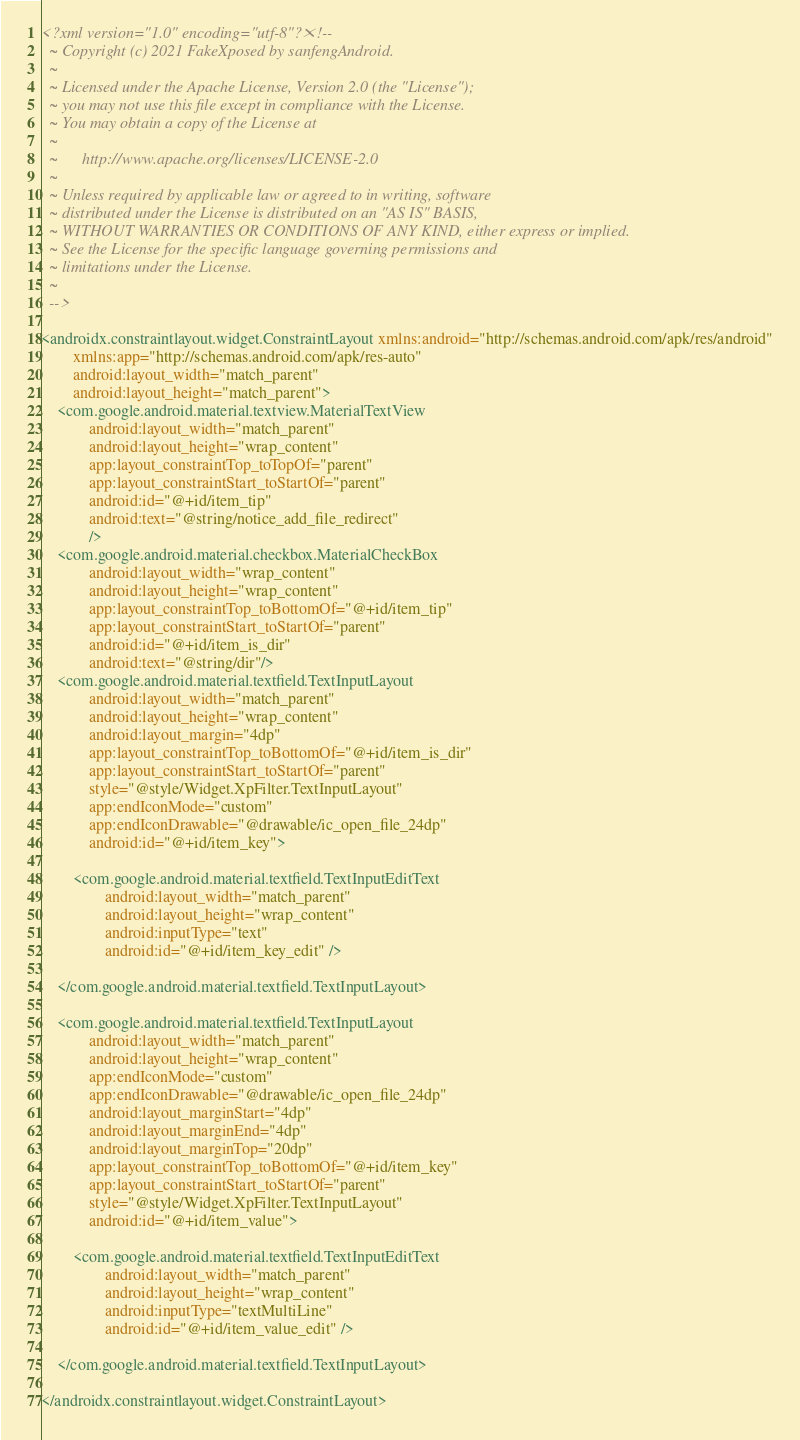Convert code to text. <code><loc_0><loc_0><loc_500><loc_500><_XML_><?xml version="1.0" encoding="utf-8"?><!--
  ~ Copyright (c) 2021 FakeXposed by sanfengAndroid.
  ~
  ~ Licensed under the Apache License, Version 2.0 (the "License");
  ~ you may not use this file except in compliance with the License.
  ~ You may obtain a copy of the License at
  ~
  ~      http://www.apache.org/licenses/LICENSE-2.0
  ~
  ~ Unless required by applicable law or agreed to in writing, software
  ~ distributed under the License is distributed on an "AS IS" BASIS,
  ~ WITHOUT WARRANTIES OR CONDITIONS OF ANY KIND, either express or implied.
  ~ See the License for the specific language governing permissions and
  ~ limitations under the License.
  ~
  -->

<androidx.constraintlayout.widget.ConstraintLayout xmlns:android="http://schemas.android.com/apk/res/android"
        xmlns:app="http://schemas.android.com/apk/res-auto"
        android:layout_width="match_parent"
        android:layout_height="match_parent">
    <com.google.android.material.textview.MaterialTextView
            android:layout_width="match_parent"
            android:layout_height="wrap_content"
            app:layout_constraintTop_toTopOf="parent"
            app:layout_constraintStart_toStartOf="parent"
            android:id="@+id/item_tip"
            android:text="@string/notice_add_file_redirect"
            />
    <com.google.android.material.checkbox.MaterialCheckBox
            android:layout_width="wrap_content"
            android:layout_height="wrap_content"
            app:layout_constraintTop_toBottomOf="@+id/item_tip"
            app:layout_constraintStart_toStartOf="parent"
            android:id="@+id/item_is_dir"
            android:text="@string/dir"/>
    <com.google.android.material.textfield.TextInputLayout
            android:layout_width="match_parent"
            android:layout_height="wrap_content"
            android:layout_margin="4dp"
            app:layout_constraintTop_toBottomOf="@+id/item_is_dir"
            app:layout_constraintStart_toStartOf="parent"
            style="@style/Widget.XpFilter.TextInputLayout"
            app:endIconMode="custom"
            app:endIconDrawable="@drawable/ic_open_file_24dp"
            android:id="@+id/item_key">

        <com.google.android.material.textfield.TextInputEditText
                android:layout_width="match_parent"
                android:layout_height="wrap_content"
                android:inputType="text"
                android:id="@+id/item_key_edit" />

    </com.google.android.material.textfield.TextInputLayout>

    <com.google.android.material.textfield.TextInputLayout
            android:layout_width="match_parent"
            android:layout_height="wrap_content"
            app:endIconMode="custom"
            app:endIconDrawable="@drawable/ic_open_file_24dp"
            android:layout_marginStart="4dp"
            android:layout_marginEnd="4dp"
            android:layout_marginTop="20dp"
            app:layout_constraintTop_toBottomOf="@+id/item_key"
            app:layout_constraintStart_toStartOf="parent"
            style="@style/Widget.XpFilter.TextInputLayout"
            android:id="@+id/item_value">

        <com.google.android.material.textfield.TextInputEditText
                android:layout_width="match_parent"
                android:layout_height="wrap_content"
                android:inputType="textMultiLine"
                android:id="@+id/item_value_edit" />

    </com.google.android.material.textfield.TextInputLayout>

</androidx.constraintlayout.widget.ConstraintLayout></code> 